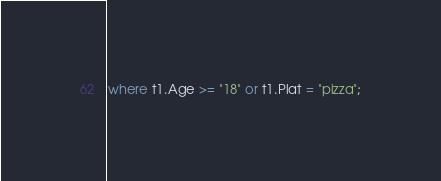<code> <loc_0><loc_0><loc_500><loc_500><_SQL_>where t1.Age >= "18" or t1.Plat = "pizza";
</code> 